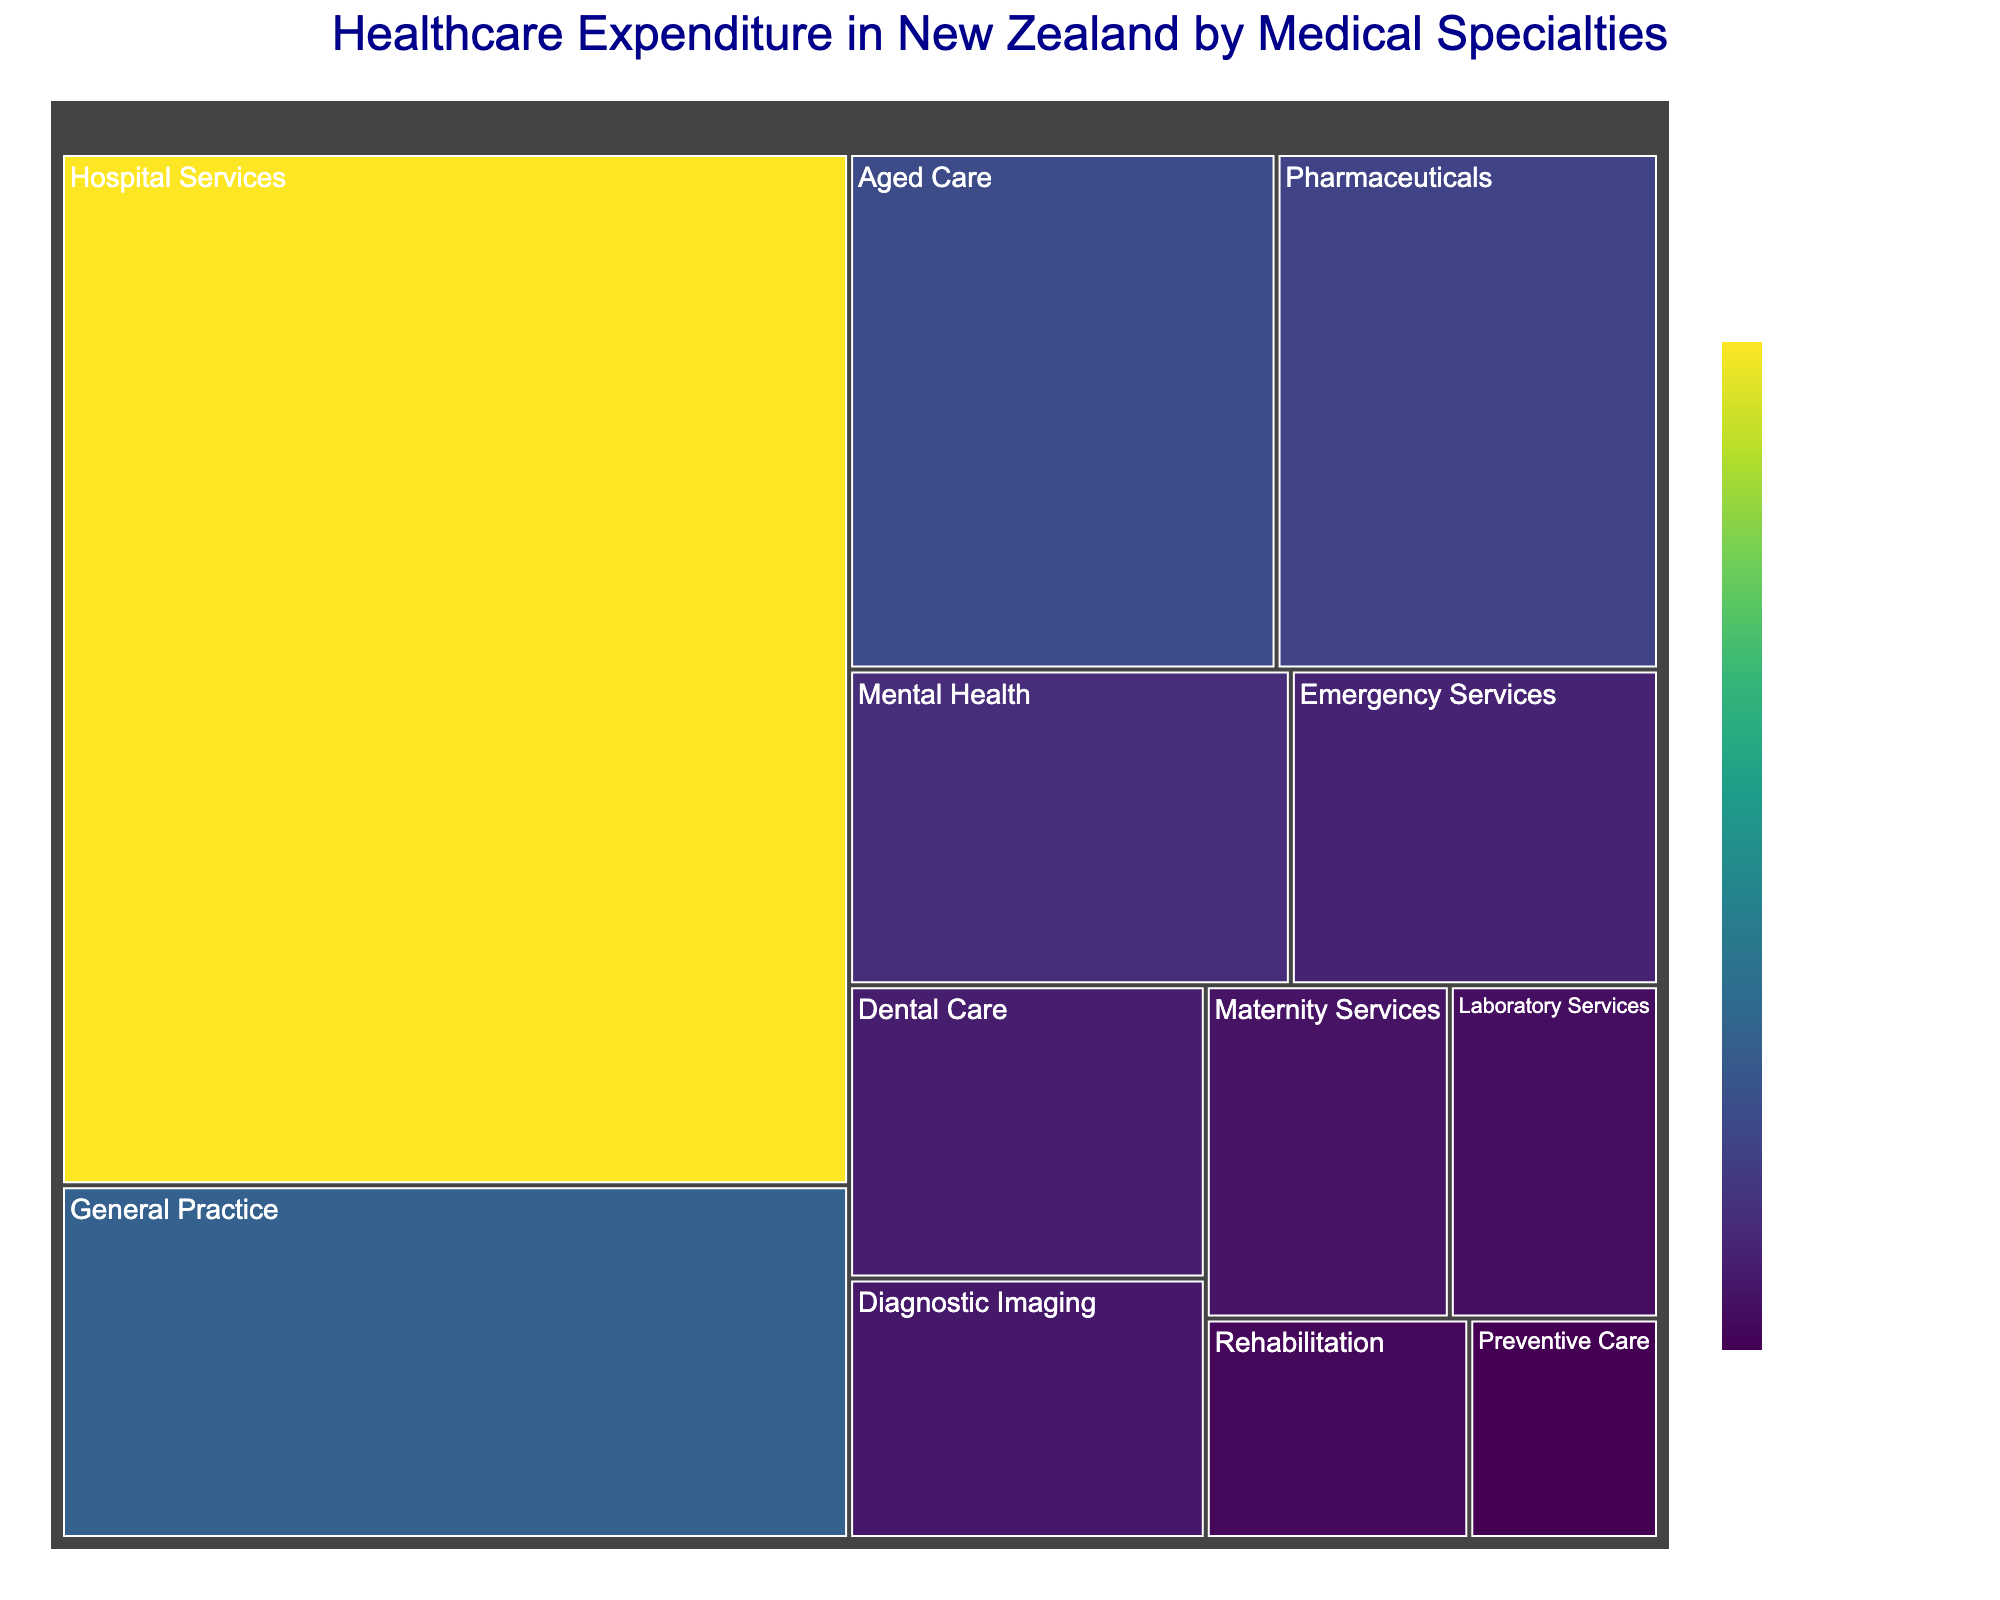What is the title of the treemap? The title is displayed at the top of the treemap, specifying the topic the figure represents. In this case, it's about healthcare expenditure by medical specialties in New Zealand.
Answer: Healthcare Expenditure in New Zealand by Medical Specialties Which medical specialty has the highest expenditure? The largest rectangle in the treemap indicates the specialty with the highest expenditure. The size and color intensity of the block help in identifying it.
Answer: Hospital Services What is the combined expenditure of General Practice and Pharmaceuticals? To find the combined expenditure, add the values of General Practice ($1,200,000,000) and Pharmaceuticals ($850,000,000). Summing these gives a total.
Answer: $2,050,000,000 How does the expenditure of Mental Health compare to that of Aged Care? Compare the expenditure values of Mental Health ($600,000,000) and Aged Care ($950,000,000). Aged Care has a higher expenditure.
Answer: Aged Care has a higher expenditure Which specialty has the lowest expenditure, and what is its value? The smallest rectangle in the treemap indicates the specialty with the lowest expenditure. Identify it by inspecting the figure.
Answer: Preventive Care, $180,000,000 Are there any specialties with the same expenditure values? Examine the expenditure values for any repetitions. In this figure, each specialty has a unique expenditure value.
Answer: No What's the difference in expenditure between Emergency Services and Diagnostic Imaging? Subtract the expenditure of Diagnostic Imaging ($400,000,000) from that of Emergency Services ($500,000,000). The difference is calculated by taking $500,000,000 - $400,000,000.
Answer: $100,000,000 How many medical specialties are listed in the figure? Count the number of distinct rectangles (specialties) displayed in the treemap.
Answer: 12 What is the average expenditure across all medical specialties? Sum all expenditures and divide by the number of specialties. The total sum is $7,700,000,000, and there are 12 specialties, so the average is $7,700,000,000 / 12.
Answer: $641,666,667 How does the expenditure of Hospital Services compare to the combined expenditure of Dental Care, Emergency Services, and Maternity Services? Calculate the sum of Dental Care ($450,000,000), Emergency Services ($500,000,000), and Maternity Services ($350,000,000), which equals $1,300,000,000. Compare this to Hospital Services ($3,500,000,000).
Answer: Hospital Services has a higher expenditure 